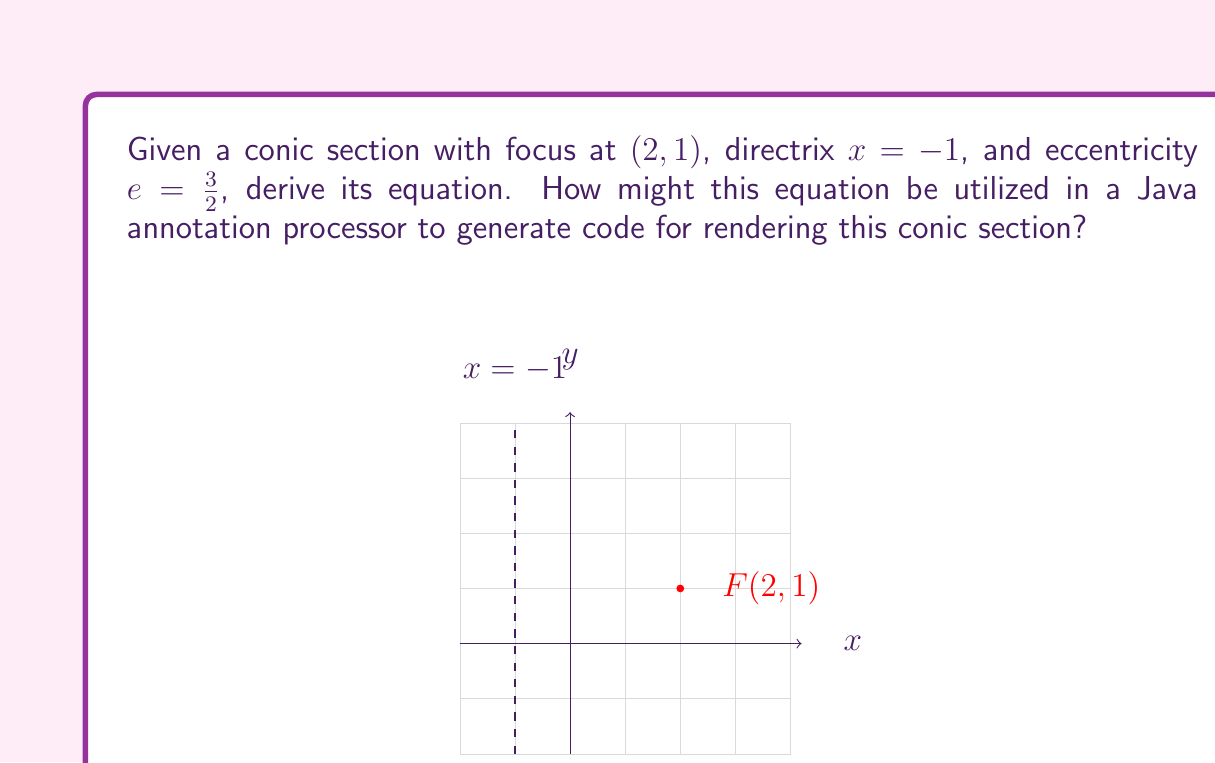Can you solve this math problem? Let's approach this step-by-step:

1) The general equation for a conic section with eccentricity $e$ is:

   $$\frac{d(P,F)}{d(P,D)} = e$$

   where $d(P,F)$ is the distance from any point $P(x,y)$ to the focus $F$, and $d(P,D)$ is the distance from $P$ to the directrix.

2) For the focus $F(2,1)$ and a point $P(x,y)$:

   $$d(P,F) = \sqrt{(x-2)^2 + (y-1)^2}$$

3) The distance from any point $P(x,y)$ to the directrix $x=-1$ is:

   $$d(P,D) = |x - (-1)| = x + 1$$

4) Substituting these into the general equation:

   $$\frac{\sqrt{(x-2)^2 + (y-1)^2}}{x + 1} = \frac{3}{2}$$

5) Square both sides to eliminate the square root:

   $$\frac{(x-2)^2 + (y-1)^2}{(x + 1)^2} = \frac{9}{4}$$

6) Multiply both sides by $(x + 1)^2$:

   $$(x-2)^2 + (y-1)^2 = \frac{9}{4}(x + 1)^2$$

7) Expand the squares:

   $$x^2 - 4x + 4 + y^2 - 2y + 1 = \frac{9}{4}(x^2 + 2x + 1)$$

8) Simplify:

   $$x^2 - 4x + y^2 - 2y + 5 = \frac{9}{4}x^2 + \frac{9}{2}x + \frac{9}{4}$$

9) Subtract $x^2$ from both sides and multiply everything by 4:

   $$-3x^2 - 16x + 4y^2 - 8y + 20 = 9x^2 + 18x + 9$$

10) Rearrange to standard form:

    $$4y^2 - 12x^2 - 8y - 34x + 11 = 0$$

For a Java annotation processor, this equation could be used to generate code for rendering the conic section. The processor could create a method that takes x and y coordinates as input and returns whether the point lies on the conic section. For example:

```java
@GenerateConic(focus="2,1", directrix="x=-1", eccentricity="1.5")
public boolean isOnConic(double x, double y) {
    return 4*y*y - 12*x*x - 8*y - 34*x + 11 == 0;
}
```

The annotation processor would generate this method based on the parameters in the @GenerateConic annotation.
Answer: $4y^2 - 12x^2 - 8y - 34x + 11 = 0$ 